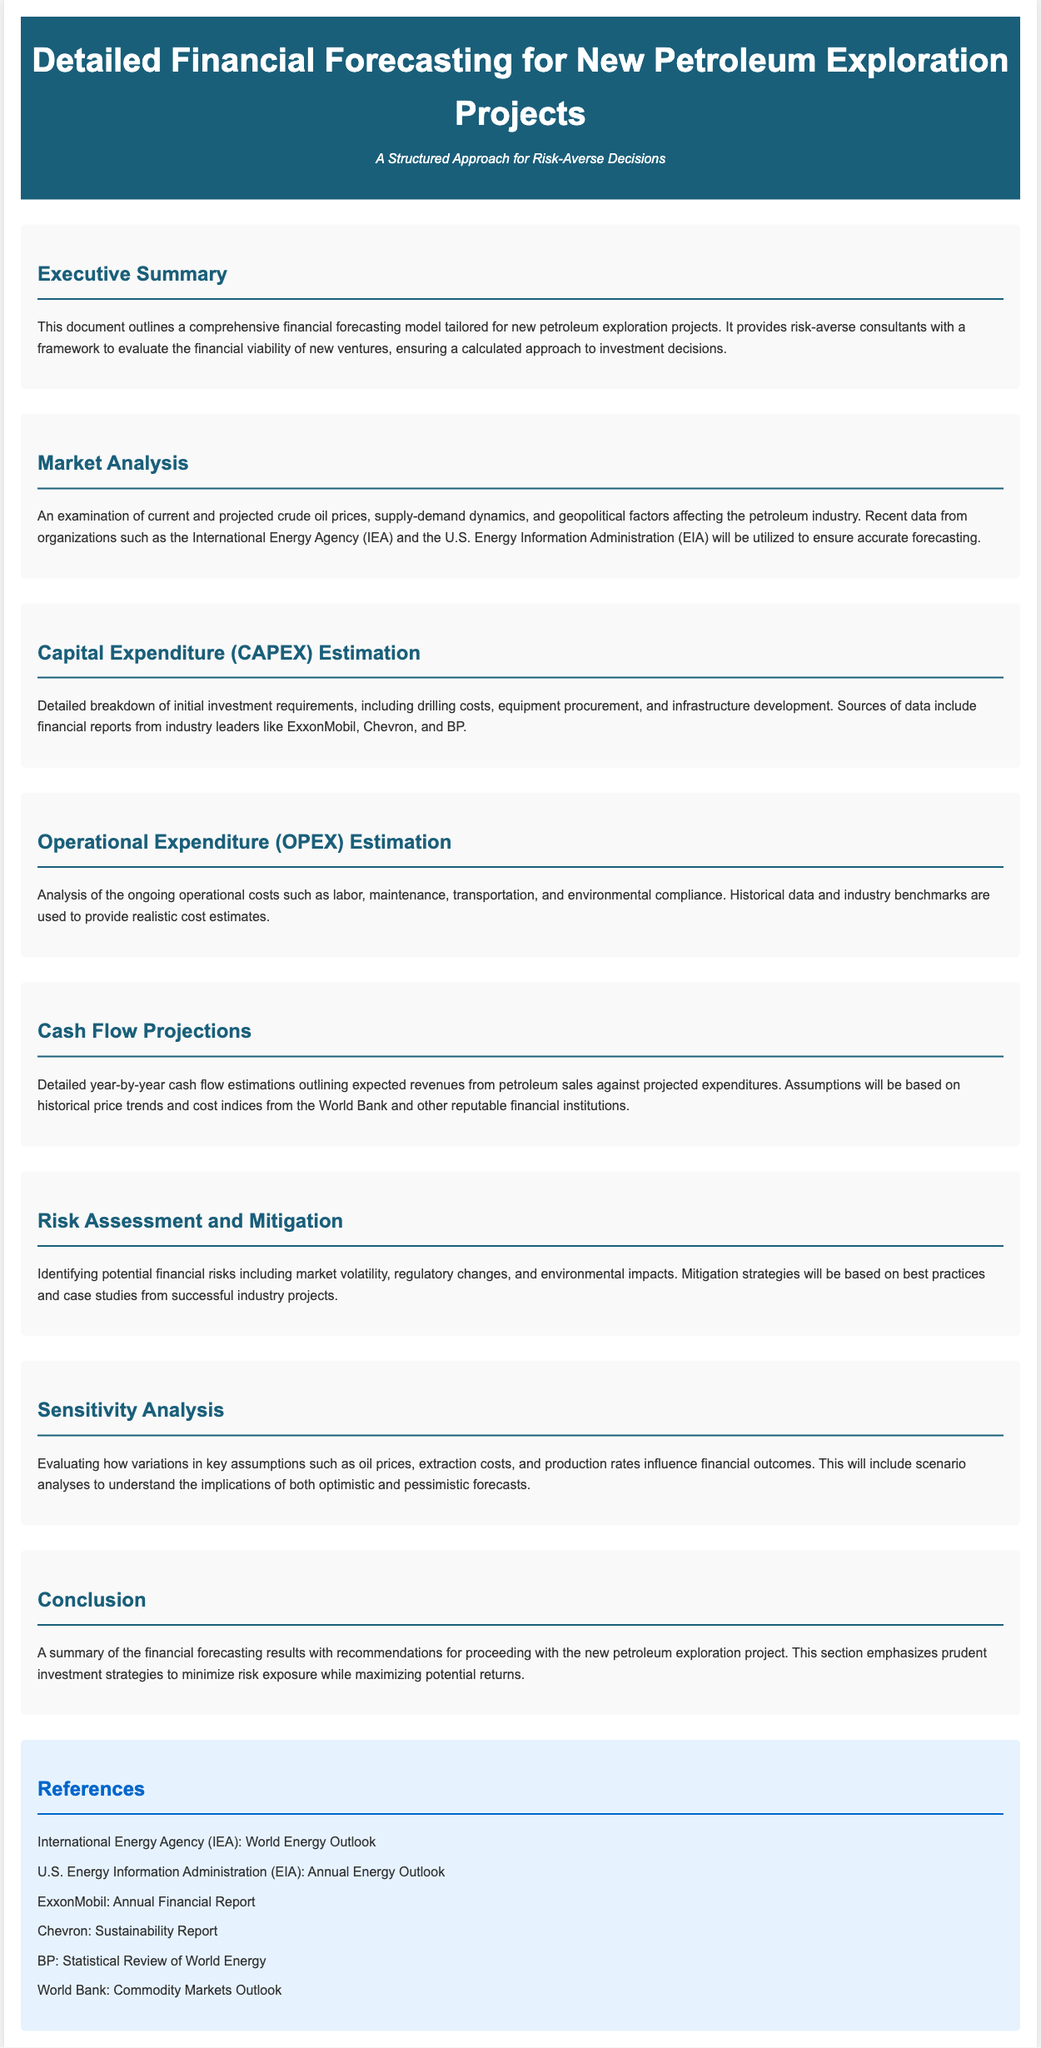What is the title of the document? The title is clearly stated in the header of the document, which outlines the main topic of discussion.
Answer: Detailed Financial Forecasting for New Petroleum Exploration Projects What does the subtitle emphasize? The subtitle suggests the document offers a structured method for a specific audience, indicating its focus on cautious decision-making.
Answer: A Structured Approach for Risk-Averse Decisions Which organization provides data for market analysis? The document mentions significant sources that would be used for accurate forecasting related to the crude oil markets.
Answer: International Energy Agency (IEA) What is included in the CAPEX estimation? The document specifies components that comprise the initial investment requirements, making it clear what expenses are detailed here.
Answer: Drilling costs, equipment procurement, and infrastructure development What are the ongoing costs analyzed in the OPEX estimation? This section identifies the recurring expenses associated with the operation, explicitly stating areas of expenditure.
Answer: Labor, maintenance, transportation, and environmental compliance What type of financial analysis evaluates key assumptions? This section highlights the method used to examine how various factors affect financial outcomes, indicating its analytical focus.
Answer: Sensitivity Analysis What is the purpose of the conclusion section? The conclusion serves to summarize findings and establish actionable recommendations, highlighting the overall goals.
Answer: Recommendations for proceeding with the new petroleum exploration project Which document discusses cash flow projections? The document explicitly outlines expected revenues against projected expenditures, focusing on financial forecasting.
Answer: Cash Flow Projections 